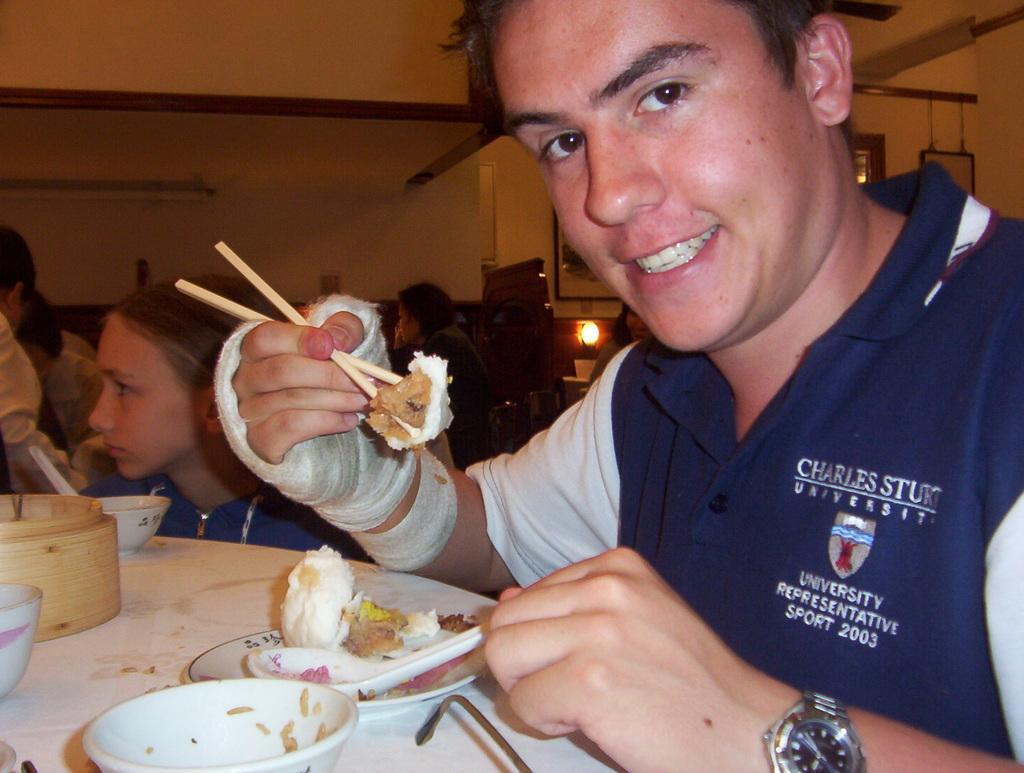Can you describe this image briefly? In the image there is a person in navy blue t-shirt holding food with chopsticks on a dining table along with some bowls on it, in the background there are few other people sitting. 